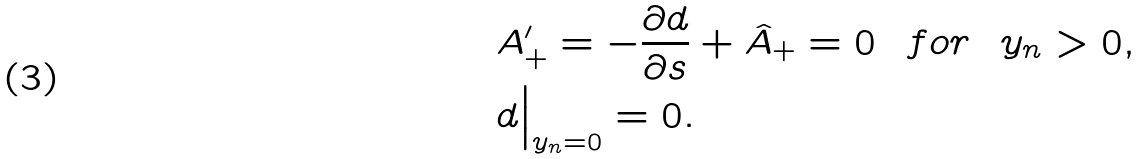Convert formula to latex. <formula><loc_0><loc_0><loc_500><loc_500>& A _ { + } ^ { \prime } = - \frac { \partial d } { \partial s } + \hat { A } _ { + } = 0 \ \ f o r \ \ y _ { n } > 0 , \\ & d \Big | _ { y _ { n } = 0 } = 0 .</formula> 